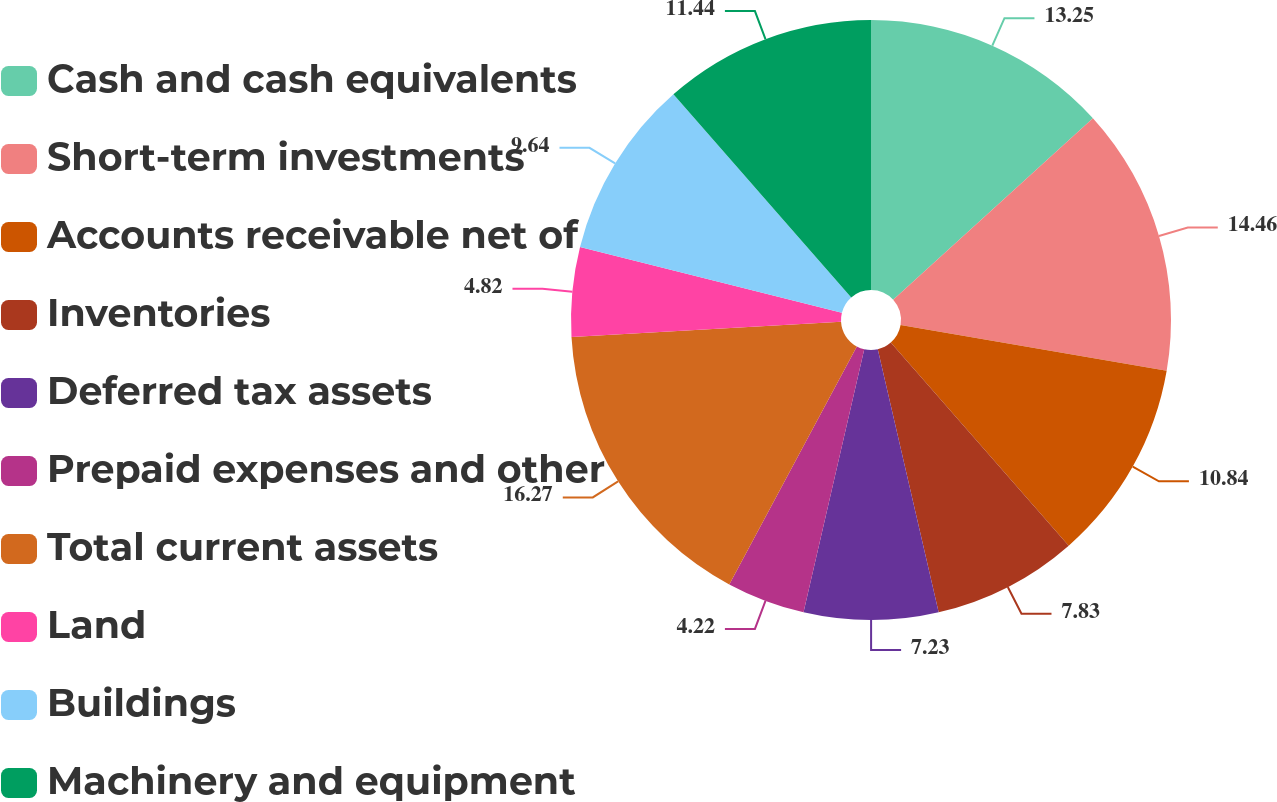<chart> <loc_0><loc_0><loc_500><loc_500><pie_chart><fcel>Cash and cash equivalents<fcel>Short-term investments<fcel>Accounts receivable net of<fcel>Inventories<fcel>Deferred tax assets<fcel>Prepaid expenses and other<fcel>Total current assets<fcel>Land<fcel>Buildings<fcel>Machinery and equipment<nl><fcel>13.25%<fcel>14.45%<fcel>10.84%<fcel>7.83%<fcel>7.23%<fcel>4.22%<fcel>16.26%<fcel>4.82%<fcel>9.64%<fcel>11.44%<nl></chart> 